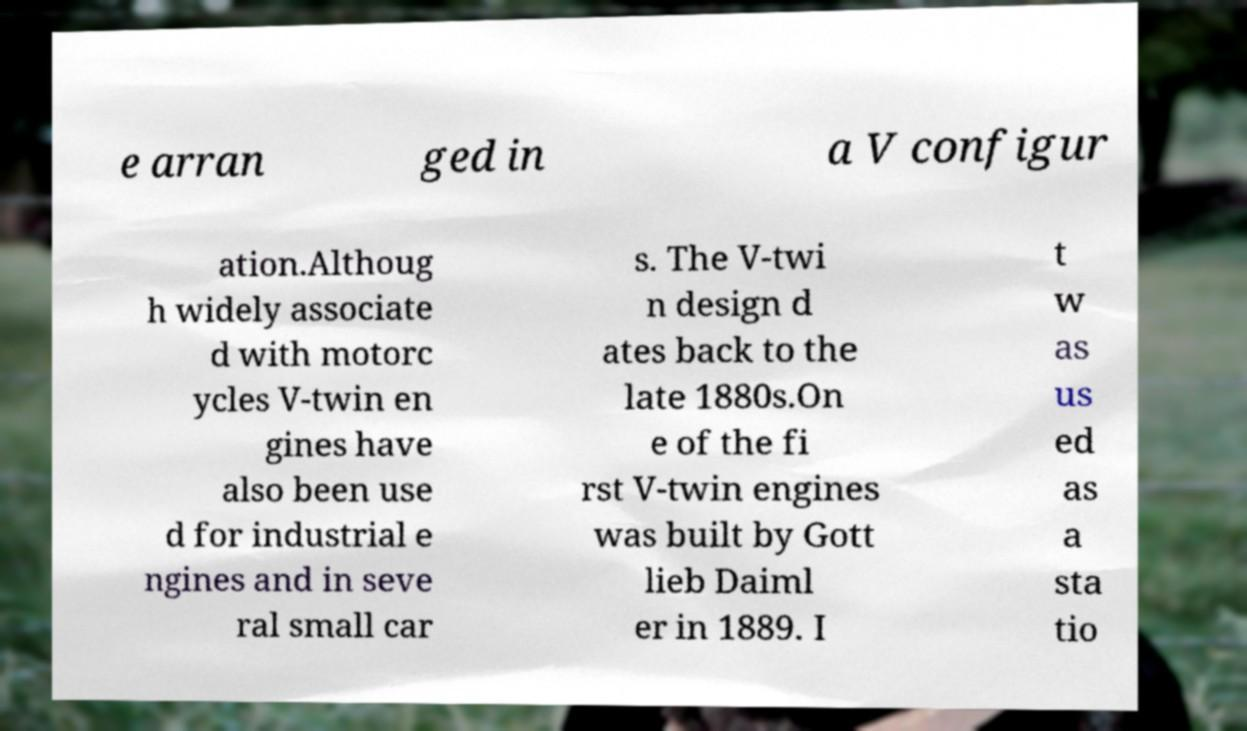Can you accurately transcribe the text from the provided image for me? e arran ged in a V configur ation.Althoug h widely associate d with motorc ycles V-twin en gines have also been use d for industrial e ngines and in seve ral small car s. The V-twi n design d ates back to the late 1880s.On e of the fi rst V-twin engines was built by Gott lieb Daiml er in 1889. I t w as us ed as a sta tio 